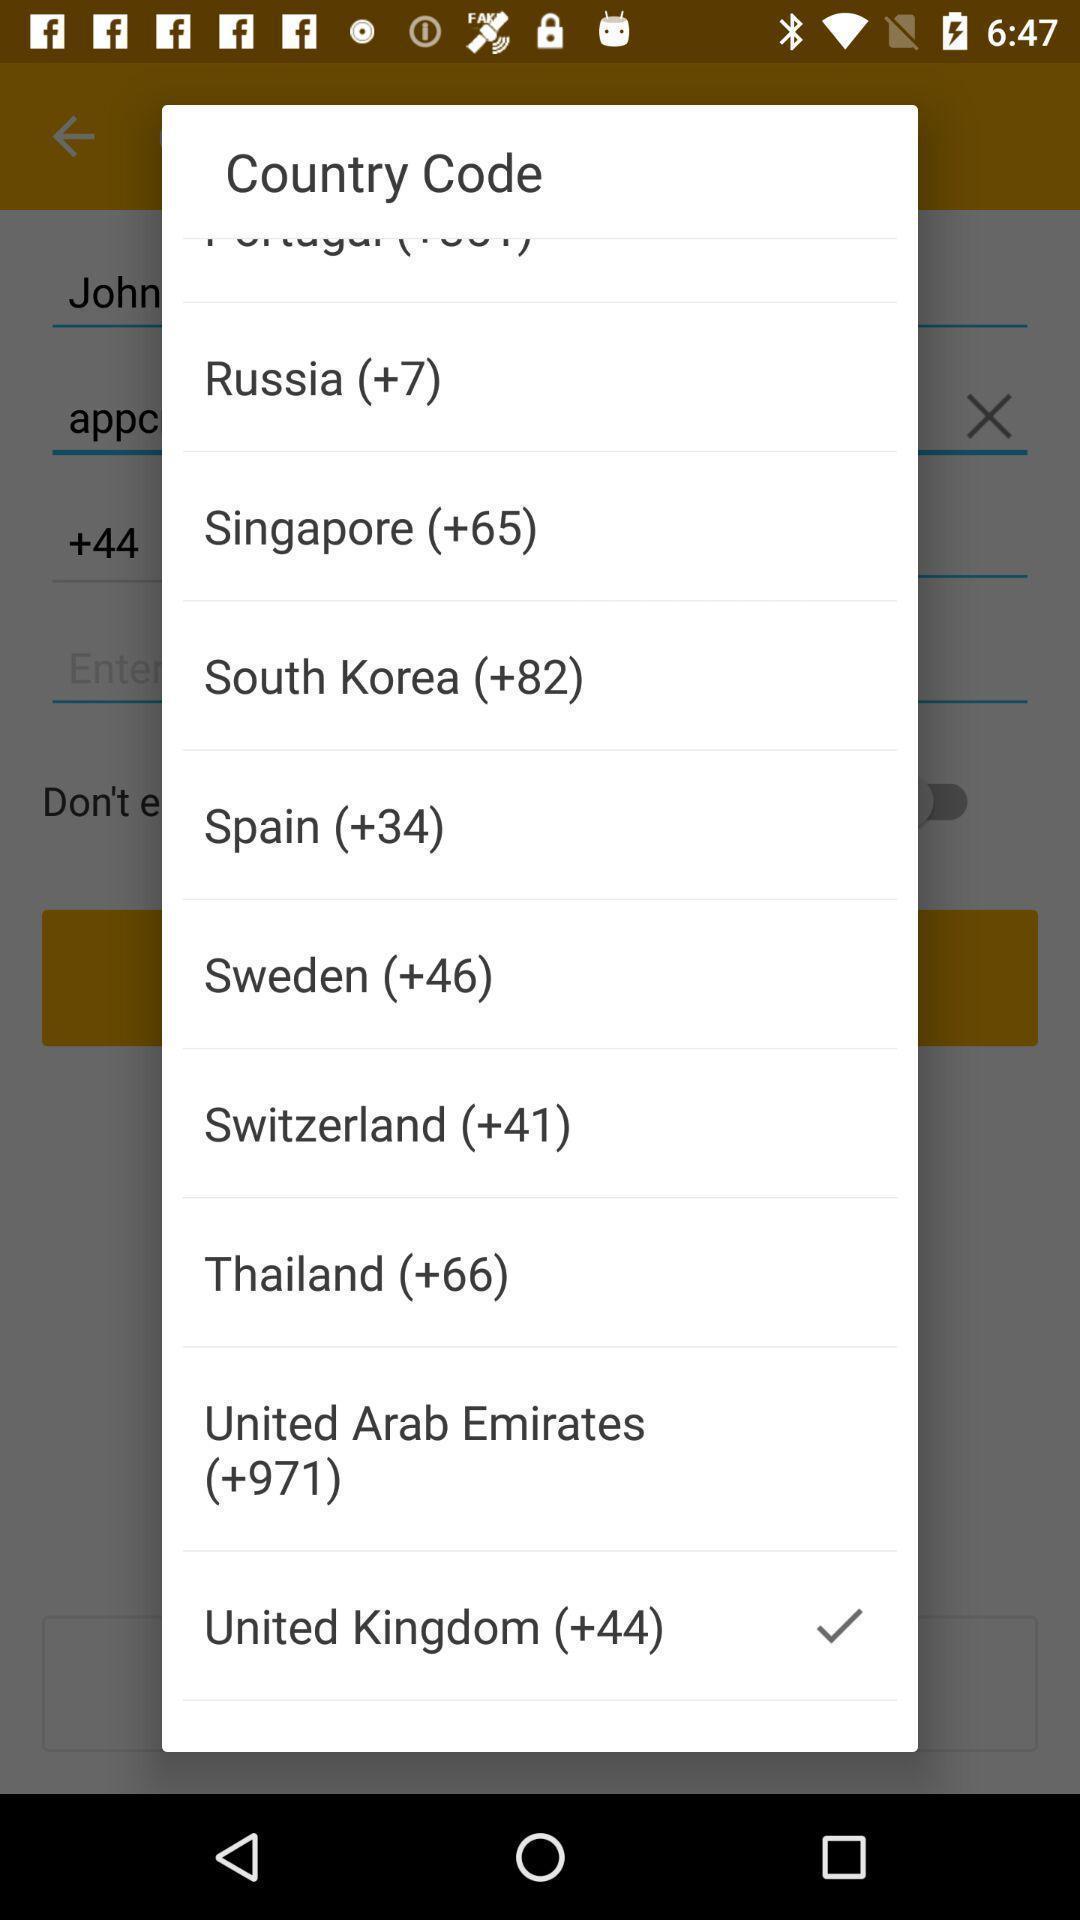Provide a textual representation of this image. Popup of different countries with codes to select. 